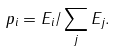<formula> <loc_0><loc_0><loc_500><loc_500>p _ { i } = E _ { i } / \sum _ { j } E _ { j } .</formula> 